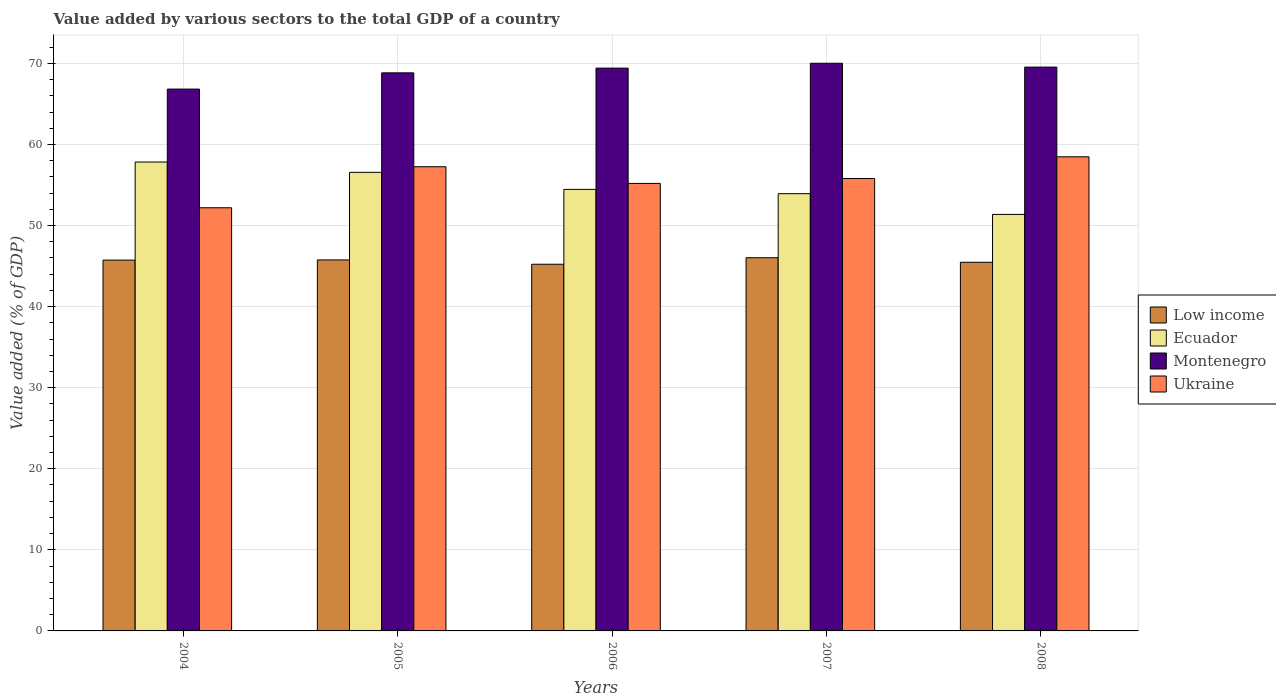How many different coloured bars are there?
Offer a very short reply. 4. How many groups of bars are there?
Provide a succinct answer. 5. Are the number of bars on each tick of the X-axis equal?
Provide a succinct answer. Yes. How many bars are there on the 3rd tick from the right?
Provide a succinct answer. 4. What is the value added by various sectors to the total GDP in Montenegro in 2005?
Offer a very short reply. 68.84. Across all years, what is the maximum value added by various sectors to the total GDP in Montenegro?
Ensure brevity in your answer.  70.02. Across all years, what is the minimum value added by various sectors to the total GDP in Ukraine?
Ensure brevity in your answer.  52.2. What is the total value added by various sectors to the total GDP in Montenegro in the graph?
Your response must be concise. 344.65. What is the difference between the value added by various sectors to the total GDP in Low income in 2005 and that in 2006?
Your answer should be compact. 0.53. What is the difference between the value added by various sectors to the total GDP in Ecuador in 2007 and the value added by various sectors to the total GDP in Low income in 2008?
Make the answer very short. 8.46. What is the average value added by various sectors to the total GDP in Ukraine per year?
Your answer should be very brief. 55.79. In the year 2005, what is the difference between the value added by various sectors to the total GDP in Ukraine and value added by various sectors to the total GDP in Low income?
Your answer should be very brief. 11.49. In how many years, is the value added by various sectors to the total GDP in Low income greater than 26 %?
Your response must be concise. 5. What is the ratio of the value added by various sectors to the total GDP in Ukraine in 2004 to that in 2006?
Your response must be concise. 0.95. Is the value added by various sectors to the total GDP in Ecuador in 2004 less than that in 2006?
Offer a very short reply. No. What is the difference between the highest and the second highest value added by various sectors to the total GDP in Ukraine?
Offer a terse response. 1.22. What is the difference between the highest and the lowest value added by various sectors to the total GDP in Ukraine?
Offer a terse response. 6.28. In how many years, is the value added by various sectors to the total GDP in Ecuador greater than the average value added by various sectors to the total GDP in Ecuador taken over all years?
Keep it short and to the point. 2. Is the sum of the value added by various sectors to the total GDP in Ecuador in 2005 and 2007 greater than the maximum value added by various sectors to the total GDP in Low income across all years?
Your response must be concise. Yes. What does the 3rd bar from the left in 2008 represents?
Your answer should be compact. Montenegro. What does the 2nd bar from the right in 2007 represents?
Make the answer very short. Montenegro. Is it the case that in every year, the sum of the value added by various sectors to the total GDP in Ecuador and value added by various sectors to the total GDP in Ukraine is greater than the value added by various sectors to the total GDP in Montenegro?
Keep it short and to the point. Yes. Are all the bars in the graph horizontal?
Provide a succinct answer. No. What is the difference between two consecutive major ticks on the Y-axis?
Offer a terse response. 10. Where does the legend appear in the graph?
Offer a very short reply. Center right. What is the title of the graph?
Offer a terse response. Value added by various sectors to the total GDP of a country. Does "West Bank and Gaza" appear as one of the legend labels in the graph?
Make the answer very short. No. What is the label or title of the X-axis?
Provide a succinct answer. Years. What is the label or title of the Y-axis?
Provide a short and direct response. Value added (% of GDP). What is the Value added (% of GDP) in Low income in 2004?
Your response must be concise. 45.74. What is the Value added (% of GDP) of Ecuador in 2004?
Your response must be concise. 57.84. What is the Value added (% of GDP) of Montenegro in 2004?
Provide a succinct answer. 66.83. What is the Value added (% of GDP) in Ukraine in 2004?
Give a very brief answer. 52.2. What is the Value added (% of GDP) of Low income in 2005?
Ensure brevity in your answer.  45.76. What is the Value added (% of GDP) of Ecuador in 2005?
Make the answer very short. 56.57. What is the Value added (% of GDP) of Montenegro in 2005?
Ensure brevity in your answer.  68.84. What is the Value added (% of GDP) in Ukraine in 2005?
Make the answer very short. 57.26. What is the Value added (% of GDP) in Low income in 2006?
Make the answer very short. 45.23. What is the Value added (% of GDP) of Ecuador in 2006?
Provide a succinct answer. 54.46. What is the Value added (% of GDP) in Montenegro in 2006?
Offer a very short reply. 69.42. What is the Value added (% of GDP) in Ukraine in 2006?
Your answer should be very brief. 55.2. What is the Value added (% of GDP) of Low income in 2007?
Ensure brevity in your answer.  46.03. What is the Value added (% of GDP) in Ecuador in 2007?
Your response must be concise. 53.93. What is the Value added (% of GDP) in Montenegro in 2007?
Make the answer very short. 70.02. What is the Value added (% of GDP) of Ukraine in 2007?
Offer a very short reply. 55.81. What is the Value added (% of GDP) of Low income in 2008?
Offer a very short reply. 45.47. What is the Value added (% of GDP) of Ecuador in 2008?
Give a very brief answer. 51.37. What is the Value added (% of GDP) of Montenegro in 2008?
Provide a short and direct response. 69.54. What is the Value added (% of GDP) of Ukraine in 2008?
Your response must be concise. 58.48. Across all years, what is the maximum Value added (% of GDP) of Low income?
Your response must be concise. 46.03. Across all years, what is the maximum Value added (% of GDP) in Ecuador?
Ensure brevity in your answer.  57.84. Across all years, what is the maximum Value added (% of GDP) in Montenegro?
Your answer should be very brief. 70.02. Across all years, what is the maximum Value added (% of GDP) of Ukraine?
Give a very brief answer. 58.48. Across all years, what is the minimum Value added (% of GDP) in Low income?
Your response must be concise. 45.23. Across all years, what is the minimum Value added (% of GDP) in Ecuador?
Provide a succinct answer. 51.37. Across all years, what is the minimum Value added (% of GDP) of Montenegro?
Keep it short and to the point. 66.83. Across all years, what is the minimum Value added (% of GDP) of Ukraine?
Make the answer very short. 52.2. What is the total Value added (% of GDP) of Low income in the graph?
Provide a succinct answer. 228.23. What is the total Value added (% of GDP) in Ecuador in the graph?
Keep it short and to the point. 274.17. What is the total Value added (% of GDP) in Montenegro in the graph?
Provide a succinct answer. 344.65. What is the total Value added (% of GDP) of Ukraine in the graph?
Give a very brief answer. 278.93. What is the difference between the Value added (% of GDP) of Low income in 2004 and that in 2005?
Offer a very short reply. -0.02. What is the difference between the Value added (% of GDP) of Ecuador in 2004 and that in 2005?
Ensure brevity in your answer.  1.27. What is the difference between the Value added (% of GDP) of Montenegro in 2004 and that in 2005?
Your answer should be compact. -2. What is the difference between the Value added (% of GDP) in Ukraine in 2004 and that in 2005?
Give a very brief answer. -5.06. What is the difference between the Value added (% of GDP) in Low income in 2004 and that in 2006?
Your answer should be compact. 0.51. What is the difference between the Value added (% of GDP) in Ecuador in 2004 and that in 2006?
Provide a succinct answer. 3.38. What is the difference between the Value added (% of GDP) in Montenegro in 2004 and that in 2006?
Ensure brevity in your answer.  -2.59. What is the difference between the Value added (% of GDP) in Ukraine in 2004 and that in 2006?
Keep it short and to the point. -3. What is the difference between the Value added (% of GDP) of Low income in 2004 and that in 2007?
Offer a terse response. -0.3. What is the difference between the Value added (% of GDP) in Ecuador in 2004 and that in 2007?
Make the answer very short. 3.91. What is the difference between the Value added (% of GDP) of Montenegro in 2004 and that in 2007?
Ensure brevity in your answer.  -3.19. What is the difference between the Value added (% of GDP) in Ukraine in 2004 and that in 2007?
Provide a short and direct response. -3.61. What is the difference between the Value added (% of GDP) in Low income in 2004 and that in 2008?
Offer a terse response. 0.27. What is the difference between the Value added (% of GDP) of Ecuador in 2004 and that in 2008?
Offer a very short reply. 6.46. What is the difference between the Value added (% of GDP) in Montenegro in 2004 and that in 2008?
Offer a terse response. -2.71. What is the difference between the Value added (% of GDP) of Ukraine in 2004 and that in 2008?
Keep it short and to the point. -6.28. What is the difference between the Value added (% of GDP) in Low income in 2005 and that in 2006?
Offer a very short reply. 0.53. What is the difference between the Value added (% of GDP) in Ecuador in 2005 and that in 2006?
Your response must be concise. 2.1. What is the difference between the Value added (% of GDP) of Montenegro in 2005 and that in 2006?
Make the answer very short. -0.58. What is the difference between the Value added (% of GDP) in Ukraine in 2005 and that in 2006?
Your response must be concise. 2.06. What is the difference between the Value added (% of GDP) of Low income in 2005 and that in 2007?
Your answer should be very brief. -0.27. What is the difference between the Value added (% of GDP) in Ecuador in 2005 and that in 2007?
Offer a very short reply. 2.63. What is the difference between the Value added (% of GDP) of Montenegro in 2005 and that in 2007?
Your answer should be compact. -1.18. What is the difference between the Value added (% of GDP) in Ukraine in 2005 and that in 2007?
Make the answer very short. 1.45. What is the difference between the Value added (% of GDP) of Low income in 2005 and that in 2008?
Ensure brevity in your answer.  0.29. What is the difference between the Value added (% of GDP) of Ecuador in 2005 and that in 2008?
Keep it short and to the point. 5.19. What is the difference between the Value added (% of GDP) of Montenegro in 2005 and that in 2008?
Provide a succinct answer. -0.71. What is the difference between the Value added (% of GDP) in Ukraine in 2005 and that in 2008?
Offer a terse response. -1.22. What is the difference between the Value added (% of GDP) in Low income in 2006 and that in 2007?
Your answer should be very brief. -0.81. What is the difference between the Value added (% of GDP) in Ecuador in 2006 and that in 2007?
Your response must be concise. 0.53. What is the difference between the Value added (% of GDP) in Montenegro in 2006 and that in 2007?
Make the answer very short. -0.6. What is the difference between the Value added (% of GDP) of Ukraine in 2006 and that in 2007?
Your answer should be very brief. -0.61. What is the difference between the Value added (% of GDP) in Low income in 2006 and that in 2008?
Make the answer very short. -0.24. What is the difference between the Value added (% of GDP) of Ecuador in 2006 and that in 2008?
Your answer should be very brief. 3.09. What is the difference between the Value added (% of GDP) of Montenegro in 2006 and that in 2008?
Your answer should be compact. -0.12. What is the difference between the Value added (% of GDP) in Ukraine in 2006 and that in 2008?
Provide a short and direct response. -3.28. What is the difference between the Value added (% of GDP) of Low income in 2007 and that in 2008?
Offer a terse response. 0.56. What is the difference between the Value added (% of GDP) in Ecuador in 2007 and that in 2008?
Give a very brief answer. 2.56. What is the difference between the Value added (% of GDP) of Montenegro in 2007 and that in 2008?
Provide a short and direct response. 0.47. What is the difference between the Value added (% of GDP) of Ukraine in 2007 and that in 2008?
Your response must be concise. -2.67. What is the difference between the Value added (% of GDP) of Low income in 2004 and the Value added (% of GDP) of Ecuador in 2005?
Provide a succinct answer. -10.83. What is the difference between the Value added (% of GDP) of Low income in 2004 and the Value added (% of GDP) of Montenegro in 2005?
Ensure brevity in your answer.  -23.1. What is the difference between the Value added (% of GDP) in Low income in 2004 and the Value added (% of GDP) in Ukraine in 2005?
Provide a succinct answer. -11.52. What is the difference between the Value added (% of GDP) in Ecuador in 2004 and the Value added (% of GDP) in Montenegro in 2005?
Your answer should be very brief. -11. What is the difference between the Value added (% of GDP) in Ecuador in 2004 and the Value added (% of GDP) in Ukraine in 2005?
Keep it short and to the point. 0.58. What is the difference between the Value added (% of GDP) in Montenegro in 2004 and the Value added (% of GDP) in Ukraine in 2005?
Ensure brevity in your answer.  9.58. What is the difference between the Value added (% of GDP) in Low income in 2004 and the Value added (% of GDP) in Ecuador in 2006?
Your answer should be compact. -8.72. What is the difference between the Value added (% of GDP) of Low income in 2004 and the Value added (% of GDP) of Montenegro in 2006?
Keep it short and to the point. -23.68. What is the difference between the Value added (% of GDP) of Low income in 2004 and the Value added (% of GDP) of Ukraine in 2006?
Offer a terse response. -9.46. What is the difference between the Value added (% of GDP) in Ecuador in 2004 and the Value added (% of GDP) in Montenegro in 2006?
Provide a succinct answer. -11.58. What is the difference between the Value added (% of GDP) in Ecuador in 2004 and the Value added (% of GDP) in Ukraine in 2006?
Offer a very short reply. 2.64. What is the difference between the Value added (% of GDP) in Montenegro in 2004 and the Value added (% of GDP) in Ukraine in 2006?
Make the answer very short. 11.64. What is the difference between the Value added (% of GDP) in Low income in 2004 and the Value added (% of GDP) in Ecuador in 2007?
Keep it short and to the point. -8.19. What is the difference between the Value added (% of GDP) of Low income in 2004 and the Value added (% of GDP) of Montenegro in 2007?
Your answer should be compact. -24.28. What is the difference between the Value added (% of GDP) in Low income in 2004 and the Value added (% of GDP) in Ukraine in 2007?
Provide a succinct answer. -10.07. What is the difference between the Value added (% of GDP) in Ecuador in 2004 and the Value added (% of GDP) in Montenegro in 2007?
Ensure brevity in your answer.  -12.18. What is the difference between the Value added (% of GDP) in Ecuador in 2004 and the Value added (% of GDP) in Ukraine in 2007?
Provide a short and direct response. 2.03. What is the difference between the Value added (% of GDP) of Montenegro in 2004 and the Value added (% of GDP) of Ukraine in 2007?
Make the answer very short. 11.03. What is the difference between the Value added (% of GDP) in Low income in 2004 and the Value added (% of GDP) in Ecuador in 2008?
Provide a succinct answer. -5.64. What is the difference between the Value added (% of GDP) in Low income in 2004 and the Value added (% of GDP) in Montenegro in 2008?
Offer a terse response. -23.81. What is the difference between the Value added (% of GDP) in Low income in 2004 and the Value added (% of GDP) in Ukraine in 2008?
Provide a succinct answer. -12.74. What is the difference between the Value added (% of GDP) of Ecuador in 2004 and the Value added (% of GDP) of Montenegro in 2008?
Provide a short and direct response. -11.71. What is the difference between the Value added (% of GDP) of Ecuador in 2004 and the Value added (% of GDP) of Ukraine in 2008?
Offer a terse response. -0.64. What is the difference between the Value added (% of GDP) in Montenegro in 2004 and the Value added (% of GDP) in Ukraine in 2008?
Your answer should be compact. 8.35. What is the difference between the Value added (% of GDP) in Low income in 2005 and the Value added (% of GDP) in Ecuador in 2006?
Offer a terse response. -8.7. What is the difference between the Value added (% of GDP) in Low income in 2005 and the Value added (% of GDP) in Montenegro in 2006?
Give a very brief answer. -23.66. What is the difference between the Value added (% of GDP) in Low income in 2005 and the Value added (% of GDP) in Ukraine in 2006?
Ensure brevity in your answer.  -9.44. What is the difference between the Value added (% of GDP) of Ecuador in 2005 and the Value added (% of GDP) of Montenegro in 2006?
Give a very brief answer. -12.85. What is the difference between the Value added (% of GDP) in Ecuador in 2005 and the Value added (% of GDP) in Ukraine in 2006?
Your answer should be compact. 1.37. What is the difference between the Value added (% of GDP) of Montenegro in 2005 and the Value added (% of GDP) of Ukraine in 2006?
Keep it short and to the point. 13.64. What is the difference between the Value added (% of GDP) in Low income in 2005 and the Value added (% of GDP) in Ecuador in 2007?
Make the answer very short. -8.17. What is the difference between the Value added (% of GDP) in Low income in 2005 and the Value added (% of GDP) in Montenegro in 2007?
Offer a very short reply. -24.26. What is the difference between the Value added (% of GDP) in Low income in 2005 and the Value added (% of GDP) in Ukraine in 2007?
Ensure brevity in your answer.  -10.04. What is the difference between the Value added (% of GDP) in Ecuador in 2005 and the Value added (% of GDP) in Montenegro in 2007?
Make the answer very short. -13.45. What is the difference between the Value added (% of GDP) of Ecuador in 2005 and the Value added (% of GDP) of Ukraine in 2007?
Give a very brief answer. 0.76. What is the difference between the Value added (% of GDP) of Montenegro in 2005 and the Value added (% of GDP) of Ukraine in 2007?
Offer a very short reply. 13.03. What is the difference between the Value added (% of GDP) of Low income in 2005 and the Value added (% of GDP) of Ecuador in 2008?
Offer a terse response. -5.61. What is the difference between the Value added (% of GDP) of Low income in 2005 and the Value added (% of GDP) of Montenegro in 2008?
Your answer should be very brief. -23.78. What is the difference between the Value added (% of GDP) in Low income in 2005 and the Value added (% of GDP) in Ukraine in 2008?
Offer a very short reply. -12.72. What is the difference between the Value added (% of GDP) of Ecuador in 2005 and the Value added (% of GDP) of Montenegro in 2008?
Your answer should be very brief. -12.98. What is the difference between the Value added (% of GDP) in Ecuador in 2005 and the Value added (% of GDP) in Ukraine in 2008?
Give a very brief answer. -1.91. What is the difference between the Value added (% of GDP) of Montenegro in 2005 and the Value added (% of GDP) of Ukraine in 2008?
Your response must be concise. 10.36. What is the difference between the Value added (% of GDP) of Low income in 2006 and the Value added (% of GDP) of Ecuador in 2007?
Your answer should be compact. -8.7. What is the difference between the Value added (% of GDP) of Low income in 2006 and the Value added (% of GDP) of Montenegro in 2007?
Offer a very short reply. -24.79. What is the difference between the Value added (% of GDP) in Low income in 2006 and the Value added (% of GDP) in Ukraine in 2007?
Give a very brief answer. -10.58. What is the difference between the Value added (% of GDP) in Ecuador in 2006 and the Value added (% of GDP) in Montenegro in 2007?
Make the answer very short. -15.56. What is the difference between the Value added (% of GDP) of Ecuador in 2006 and the Value added (% of GDP) of Ukraine in 2007?
Provide a short and direct response. -1.34. What is the difference between the Value added (% of GDP) of Montenegro in 2006 and the Value added (% of GDP) of Ukraine in 2007?
Keep it short and to the point. 13.61. What is the difference between the Value added (% of GDP) of Low income in 2006 and the Value added (% of GDP) of Ecuador in 2008?
Provide a short and direct response. -6.15. What is the difference between the Value added (% of GDP) in Low income in 2006 and the Value added (% of GDP) in Montenegro in 2008?
Make the answer very short. -24.32. What is the difference between the Value added (% of GDP) in Low income in 2006 and the Value added (% of GDP) in Ukraine in 2008?
Your answer should be compact. -13.25. What is the difference between the Value added (% of GDP) in Ecuador in 2006 and the Value added (% of GDP) in Montenegro in 2008?
Offer a very short reply. -15.08. What is the difference between the Value added (% of GDP) of Ecuador in 2006 and the Value added (% of GDP) of Ukraine in 2008?
Ensure brevity in your answer.  -4.02. What is the difference between the Value added (% of GDP) in Montenegro in 2006 and the Value added (% of GDP) in Ukraine in 2008?
Provide a short and direct response. 10.94. What is the difference between the Value added (% of GDP) in Low income in 2007 and the Value added (% of GDP) in Ecuador in 2008?
Offer a very short reply. -5.34. What is the difference between the Value added (% of GDP) in Low income in 2007 and the Value added (% of GDP) in Montenegro in 2008?
Offer a very short reply. -23.51. What is the difference between the Value added (% of GDP) of Low income in 2007 and the Value added (% of GDP) of Ukraine in 2008?
Provide a short and direct response. -12.45. What is the difference between the Value added (% of GDP) in Ecuador in 2007 and the Value added (% of GDP) in Montenegro in 2008?
Provide a short and direct response. -15.61. What is the difference between the Value added (% of GDP) in Ecuador in 2007 and the Value added (% of GDP) in Ukraine in 2008?
Make the answer very short. -4.55. What is the difference between the Value added (% of GDP) in Montenegro in 2007 and the Value added (% of GDP) in Ukraine in 2008?
Offer a very short reply. 11.54. What is the average Value added (% of GDP) of Low income per year?
Your response must be concise. 45.65. What is the average Value added (% of GDP) in Ecuador per year?
Offer a very short reply. 54.83. What is the average Value added (% of GDP) of Montenegro per year?
Your response must be concise. 68.93. What is the average Value added (% of GDP) in Ukraine per year?
Make the answer very short. 55.79. In the year 2004, what is the difference between the Value added (% of GDP) of Low income and Value added (% of GDP) of Montenegro?
Provide a succinct answer. -21.1. In the year 2004, what is the difference between the Value added (% of GDP) in Low income and Value added (% of GDP) in Ukraine?
Ensure brevity in your answer.  -6.46. In the year 2004, what is the difference between the Value added (% of GDP) of Ecuador and Value added (% of GDP) of Montenegro?
Your answer should be compact. -9. In the year 2004, what is the difference between the Value added (% of GDP) of Ecuador and Value added (% of GDP) of Ukraine?
Offer a very short reply. 5.64. In the year 2004, what is the difference between the Value added (% of GDP) in Montenegro and Value added (% of GDP) in Ukraine?
Keep it short and to the point. 14.64. In the year 2005, what is the difference between the Value added (% of GDP) in Low income and Value added (% of GDP) in Ecuador?
Keep it short and to the point. -10.8. In the year 2005, what is the difference between the Value added (% of GDP) of Low income and Value added (% of GDP) of Montenegro?
Make the answer very short. -23.08. In the year 2005, what is the difference between the Value added (% of GDP) in Low income and Value added (% of GDP) in Ukraine?
Make the answer very short. -11.49. In the year 2005, what is the difference between the Value added (% of GDP) of Ecuador and Value added (% of GDP) of Montenegro?
Offer a terse response. -12.27. In the year 2005, what is the difference between the Value added (% of GDP) of Ecuador and Value added (% of GDP) of Ukraine?
Offer a terse response. -0.69. In the year 2005, what is the difference between the Value added (% of GDP) in Montenegro and Value added (% of GDP) in Ukraine?
Your answer should be very brief. 11.58. In the year 2006, what is the difference between the Value added (% of GDP) in Low income and Value added (% of GDP) in Ecuador?
Make the answer very short. -9.23. In the year 2006, what is the difference between the Value added (% of GDP) in Low income and Value added (% of GDP) in Montenegro?
Provide a short and direct response. -24.19. In the year 2006, what is the difference between the Value added (% of GDP) in Low income and Value added (% of GDP) in Ukraine?
Your answer should be very brief. -9.97. In the year 2006, what is the difference between the Value added (% of GDP) of Ecuador and Value added (% of GDP) of Montenegro?
Offer a terse response. -14.96. In the year 2006, what is the difference between the Value added (% of GDP) in Ecuador and Value added (% of GDP) in Ukraine?
Provide a short and direct response. -0.74. In the year 2006, what is the difference between the Value added (% of GDP) of Montenegro and Value added (% of GDP) of Ukraine?
Offer a very short reply. 14.22. In the year 2007, what is the difference between the Value added (% of GDP) of Low income and Value added (% of GDP) of Ecuador?
Offer a terse response. -7.9. In the year 2007, what is the difference between the Value added (% of GDP) of Low income and Value added (% of GDP) of Montenegro?
Your answer should be very brief. -23.98. In the year 2007, what is the difference between the Value added (% of GDP) of Low income and Value added (% of GDP) of Ukraine?
Your response must be concise. -9.77. In the year 2007, what is the difference between the Value added (% of GDP) of Ecuador and Value added (% of GDP) of Montenegro?
Offer a very short reply. -16.09. In the year 2007, what is the difference between the Value added (% of GDP) in Ecuador and Value added (% of GDP) in Ukraine?
Offer a terse response. -1.87. In the year 2007, what is the difference between the Value added (% of GDP) in Montenegro and Value added (% of GDP) in Ukraine?
Your answer should be very brief. 14.21. In the year 2008, what is the difference between the Value added (% of GDP) in Low income and Value added (% of GDP) in Ecuador?
Offer a very short reply. -5.9. In the year 2008, what is the difference between the Value added (% of GDP) of Low income and Value added (% of GDP) of Montenegro?
Provide a short and direct response. -24.07. In the year 2008, what is the difference between the Value added (% of GDP) of Low income and Value added (% of GDP) of Ukraine?
Your answer should be compact. -13.01. In the year 2008, what is the difference between the Value added (% of GDP) in Ecuador and Value added (% of GDP) in Montenegro?
Your answer should be very brief. -18.17. In the year 2008, what is the difference between the Value added (% of GDP) in Ecuador and Value added (% of GDP) in Ukraine?
Ensure brevity in your answer.  -7.11. In the year 2008, what is the difference between the Value added (% of GDP) in Montenegro and Value added (% of GDP) in Ukraine?
Keep it short and to the point. 11.07. What is the ratio of the Value added (% of GDP) in Low income in 2004 to that in 2005?
Your answer should be very brief. 1. What is the ratio of the Value added (% of GDP) in Ecuador in 2004 to that in 2005?
Make the answer very short. 1.02. What is the ratio of the Value added (% of GDP) of Montenegro in 2004 to that in 2005?
Offer a very short reply. 0.97. What is the ratio of the Value added (% of GDP) of Ukraine in 2004 to that in 2005?
Provide a succinct answer. 0.91. What is the ratio of the Value added (% of GDP) of Low income in 2004 to that in 2006?
Ensure brevity in your answer.  1.01. What is the ratio of the Value added (% of GDP) in Ecuador in 2004 to that in 2006?
Keep it short and to the point. 1.06. What is the ratio of the Value added (% of GDP) of Montenegro in 2004 to that in 2006?
Provide a succinct answer. 0.96. What is the ratio of the Value added (% of GDP) in Ukraine in 2004 to that in 2006?
Provide a succinct answer. 0.95. What is the ratio of the Value added (% of GDP) in Ecuador in 2004 to that in 2007?
Keep it short and to the point. 1.07. What is the ratio of the Value added (% of GDP) in Montenegro in 2004 to that in 2007?
Keep it short and to the point. 0.95. What is the ratio of the Value added (% of GDP) in Ukraine in 2004 to that in 2007?
Provide a short and direct response. 0.94. What is the ratio of the Value added (% of GDP) of Low income in 2004 to that in 2008?
Give a very brief answer. 1.01. What is the ratio of the Value added (% of GDP) of Ecuador in 2004 to that in 2008?
Provide a succinct answer. 1.13. What is the ratio of the Value added (% of GDP) in Montenegro in 2004 to that in 2008?
Offer a very short reply. 0.96. What is the ratio of the Value added (% of GDP) of Ukraine in 2004 to that in 2008?
Ensure brevity in your answer.  0.89. What is the ratio of the Value added (% of GDP) in Low income in 2005 to that in 2006?
Your answer should be very brief. 1.01. What is the ratio of the Value added (% of GDP) of Ecuador in 2005 to that in 2006?
Make the answer very short. 1.04. What is the ratio of the Value added (% of GDP) of Ukraine in 2005 to that in 2006?
Offer a very short reply. 1.04. What is the ratio of the Value added (% of GDP) of Ecuador in 2005 to that in 2007?
Your answer should be very brief. 1.05. What is the ratio of the Value added (% of GDP) of Montenegro in 2005 to that in 2007?
Your answer should be compact. 0.98. What is the ratio of the Value added (% of GDP) in Ukraine in 2005 to that in 2007?
Provide a short and direct response. 1.03. What is the ratio of the Value added (% of GDP) of Low income in 2005 to that in 2008?
Provide a short and direct response. 1.01. What is the ratio of the Value added (% of GDP) of Ecuador in 2005 to that in 2008?
Your response must be concise. 1.1. What is the ratio of the Value added (% of GDP) of Montenegro in 2005 to that in 2008?
Provide a short and direct response. 0.99. What is the ratio of the Value added (% of GDP) in Ukraine in 2005 to that in 2008?
Make the answer very short. 0.98. What is the ratio of the Value added (% of GDP) in Low income in 2006 to that in 2007?
Ensure brevity in your answer.  0.98. What is the ratio of the Value added (% of GDP) in Ecuador in 2006 to that in 2007?
Offer a terse response. 1.01. What is the ratio of the Value added (% of GDP) of Montenegro in 2006 to that in 2007?
Offer a terse response. 0.99. What is the ratio of the Value added (% of GDP) of Ukraine in 2006 to that in 2007?
Offer a very short reply. 0.99. What is the ratio of the Value added (% of GDP) of Low income in 2006 to that in 2008?
Offer a terse response. 0.99. What is the ratio of the Value added (% of GDP) of Ecuador in 2006 to that in 2008?
Offer a very short reply. 1.06. What is the ratio of the Value added (% of GDP) of Montenegro in 2006 to that in 2008?
Your answer should be compact. 1. What is the ratio of the Value added (% of GDP) of Ukraine in 2006 to that in 2008?
Provide a short and direct response. 0.94. What is the ratio of the Value added (% of GDP) in Low income in 2007 to that in 2008?
Provide a short and direct response. 1.01. What is the ratio of the Value added (% of GDP) of Ecuador in 2007 to that in 2008?
Give a very brief answer. 1.05. What is the ratio of the Value added (% of GDP) of Montenegro in 2007 to that in 2008?
Ensure brevity in your answer.  1.01. What is the ratio of the Value added (% of GDP) in Ukraine in 2007 to that in 2008?
Offer a terse response. 0.95. What is the difference between the highest and the second highest Value added (% of GDP) in Low income?
Provide a succinct answer. 0.27. What is the difference between the highest and the second highest Value added (% of GDP) of Ecuador?
Offer a very short reply. 1.27. What is the difference between the highest and the second highest Value added (% of GDP) in Montenegro?
Offer a very short reply. 0.47. What is the difference between the highest and the second highest Value added (% of GDP) of Ukraine?
Give a very brief answer. 1.22. What is the difference between the highest and the lowest Value added (% of GDP) in Low income?
Ensure brevity in your answer.  0.81. What is the difference between the highest and the lowest Value added (% of GDP) in Ecuador?
Give a very brief answer. 6.46. What is the difference between the highest and the lowest Value added (% of GDP) in Montenegro?
Provide a succinct answer. 3.19. What is the difference between the highest and the lowest Value added (% of GDP) in Ukraine?
Make the answer very short. 6.28. 